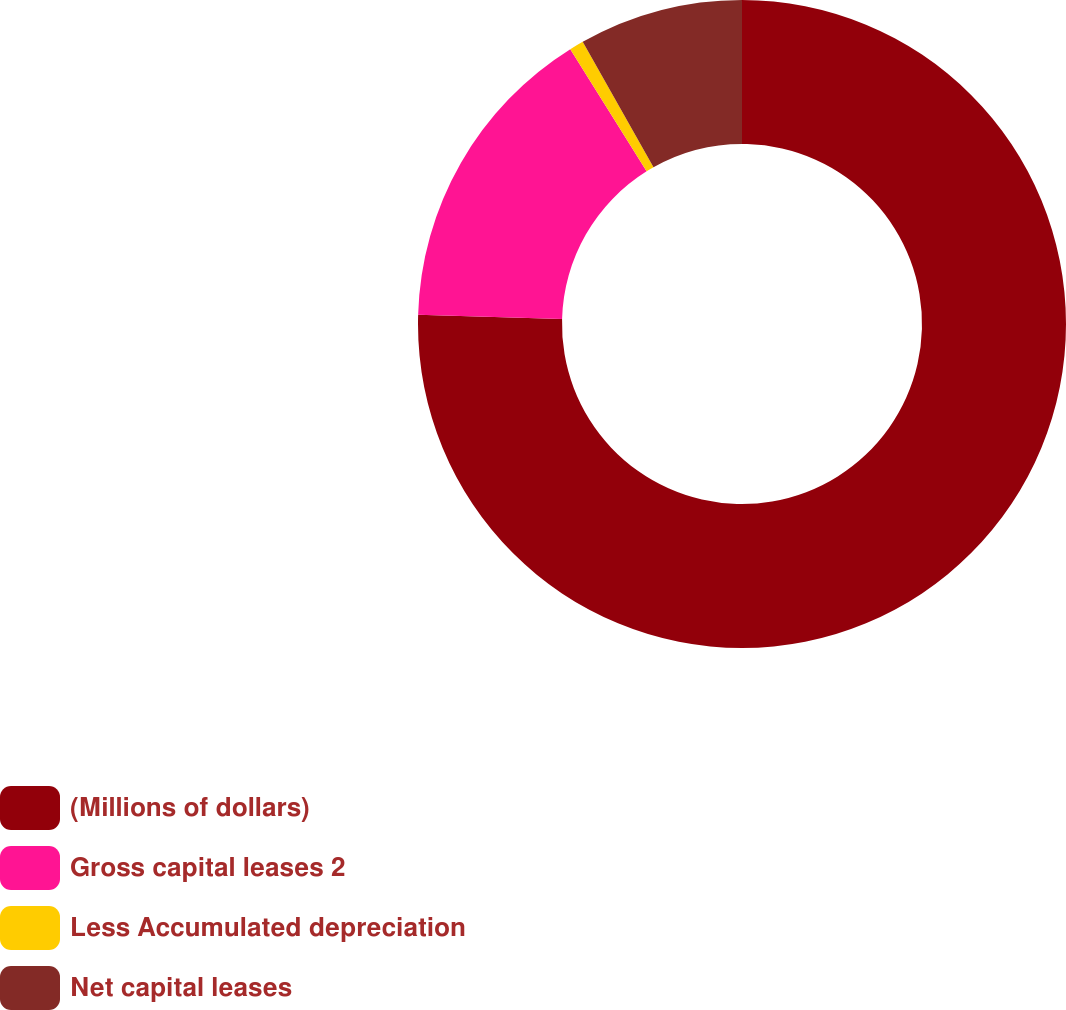<chart> <loc_0><loc_0><loc_500><loc_500><pie_chart><fcel>(Millions of dollars)<fcel>Gross capital leases 2<fcel>Less Accumulated depreciation<fcel>Net capital leases<nl><fcel>75.45%<fcel>15.66%<fcel>0.71%<fcel>8.18%<nl></chart> 